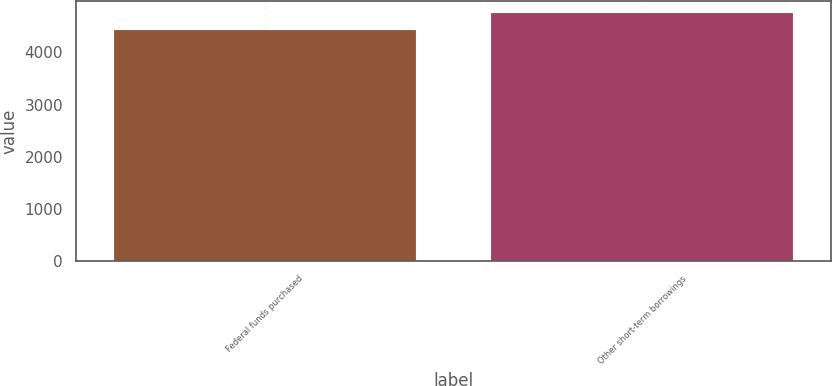Convert chart. <chart><loc_0><loc_0><loc_500><loc_500><bar_chart><fcel>Federal funds purchased<fcel>Other short-term borrowings<nl><fcel>4427<fcel>4747<nl></chart> 